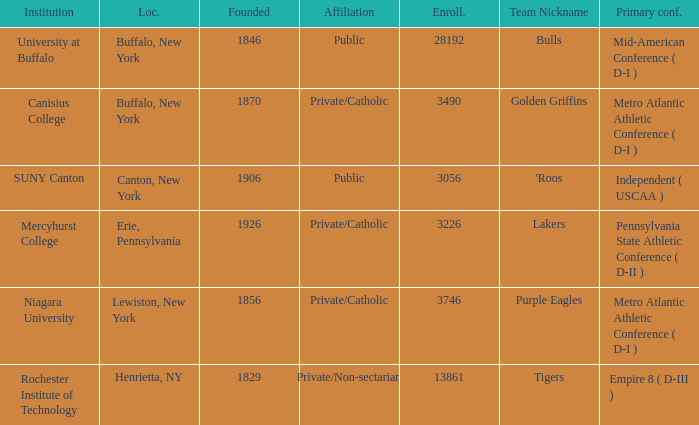What kind of school is Canton, New York? Public. 